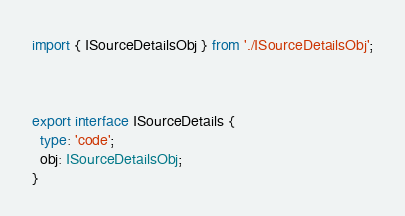Convert code to text. <code><loc_0><loc_0><loc_500><loc_500><_TypeScript_>import { ISourceDetailsObj } from './ISourceDetailsObj';



export interface ISourceDetails {
  type: 'code';
  obj: ISourceDetailsObj;
}
</code> 